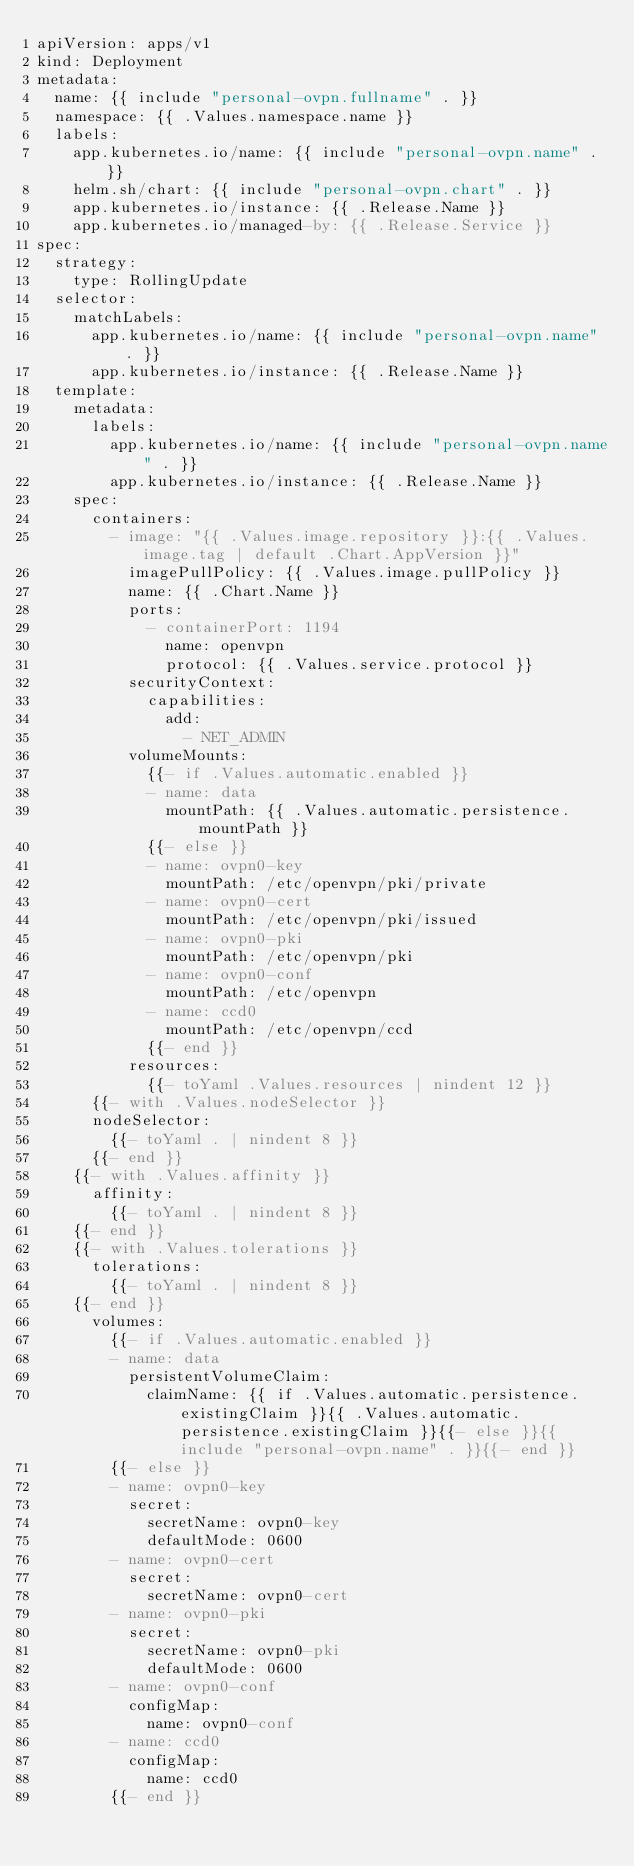<code> <loc_0><loc_0><loc_500><loc_500><_YAML_>apiVersion: apps/v1
kind: Deployment
metadata:
  name: {{ include "personal-ovpn.fullname" . }}
  namespace: {{ .Values.namespace.name }}
  labels:
    app.kubernetes.io/name: {{ include "personal-ovpn.name" . }}
    helm.sh/chart: {{ include "personal-ovpn.chart" . }}
    app.kubernetes.io/instance: {{ .Release.Name }}
    app.kubernetes.io/managed-by: {{ .Release.Service }}
spec:
  strategy:
    type: RollingUpdate
  selector:
    matchLabels:
      app.kubernetes.io/name: {{ include "personal-ovpn.name" . }}
      app.kubernetes.io/instance: {{ .Release.Name }}
  template:
    metadata:
      labels:
        app.kubernetes.io/name: {{ include "personal-ovpn.name" . }}
        app.kubernetes.io/instance: {{ .Release.Name }}
    spec:
      containers:
        - image: "{{ .Values.image.repository }}:{{ .Values.image.tag | default .Chart.AppVersion }}"
          imagePullPolicy: {{ .Values.image.pullPolicy }}
          name: {{ .Chart.Name }}
          ports:
            - containerPort: 1194
              name: openvpn
              protocol: {{ .Values.service.protocol }}
          securityContext:
            capabilities:
              add:
                - NET_ADMIN
          volumeMounts:
            {{- if .Values.automatic.enabled }}
            - name: data
              mountPath: {{ .Values.automatic.persistence.mountPath }}
            {{- else }}
            - name: ovpn0-key
              mountPath: /etc/openvpn/pki/private
            - name: ovpn0-cert
              mountPath: /etc/openvpn/pki/issued
            - name: ovpn0-pki
              mountPath: /etc/openvpn/pki
            - name: ovpn0-conf
              mountPath: /etc/openvpn
            - name: ccd0
              mountPath: /etc/openvpn/ccd
            {{- end }}
          resources:
            {{- toYaml .Values.resources | nindent 12 }}
      {{- with .Values.nodeSelector }}
      nodeSelector:
        {{- toYaml . | nindent 8 }}
      {{- end }}
    {{- with .Values.affinity }}
      affinity:
        {{- toYaml . | nindent 8 }}
    {{- end }}
    {{- with .Values.tolerations }}
      tolerations:
        {{- toYaml . | nindent 8 }}
    {{- end }}
      volumes:
        {{- if .Values.automatic.enabled }}
        - name: data
          persistentVolumeClaim:
            claimName: {{ if .Values.automatic.persistence.existingClaim }}{{ .Values.automatic.persistence.existingClaim }}{{- else }}{{ include "personal-ovpn.name" . }}{{- end }}
        {{- else }}
        - name: ovpn0-key
          secret:
            secretName: ovpn0-key
            defaultMode: 0600
        - name: ovpn0-cert
          secret:
            secretName: ovpn0-cert
        - name: ovpn0-pki
          secret:
            secretName: ovpn0-pki
            defaultMode: 0600
        - name: ovpn0-conf
          configMap:
            name: ovpn0-conf
        - name: ccd0
          configMap:
            name: ccd0
        {{- end }}
</code> 